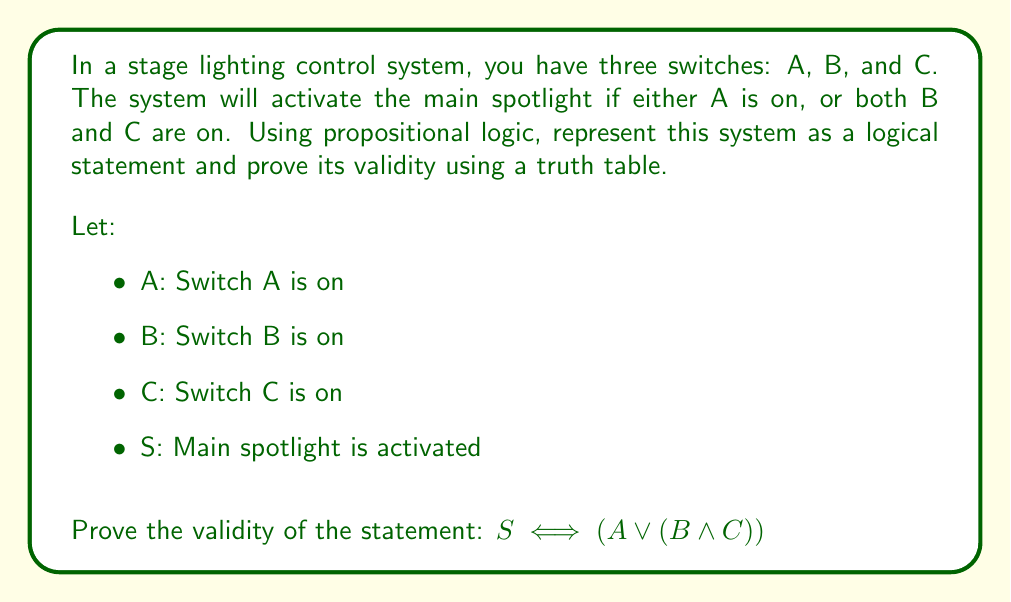Help me with this question. To prove the validity of the logical statement $S \iff (A \lor (B \land C))$, we need to construct a truth table and show that it is a tautology (always true for all possible input combinations).

Step 1: Identify the atomic propositions: A, B, and C.

Step 2: List all possible combinations of truth values for A, B, and C (8 rows).

Step 3: Evaluate the subexpression $(B \land C)$.

Step 4: Evaluate the expression $(A \lor (B \land C))$.

Step 5: Evaluate the entire biconditional statement $S \iff (A \lor (B \land C))$.

Here's the truth table:

$$
\begin{array}{|c|c|c|c|c|c|c|}
\hline
A & B & C & (B \land C) & (A \lor (B \land C)) & S & S \iff (A \lor (B \land C)) \\
\hline
T & T & T & T & T & T & T \\
T & T & F & F & T & T & T \\
T & F & T & F & T & T & T \\
T & F & F & F & T & T & T \\
F & T & T & T & T & T & T \\
F & T & F & F & F & F & T \\
F & F & T & F & F & F & T \\
F & F & F & F & F & F & T \\
\hline
\end{array}
$$

As we can see, the last column (representing the entire statement) is always true (T) for all possible combinations of input values. This proves that the statement is a tautology and, therefore, valid.

The truth table demonstrates that the spotlight (S) is indeed activated when either A is on, or both B and C are on, which matches the given logical statement.
Answer: The logical statement $S \iff (A \lor (B \land C))$ is valid, as proven by the truth table showing it is a tautology (always true for all possible input combinations). 